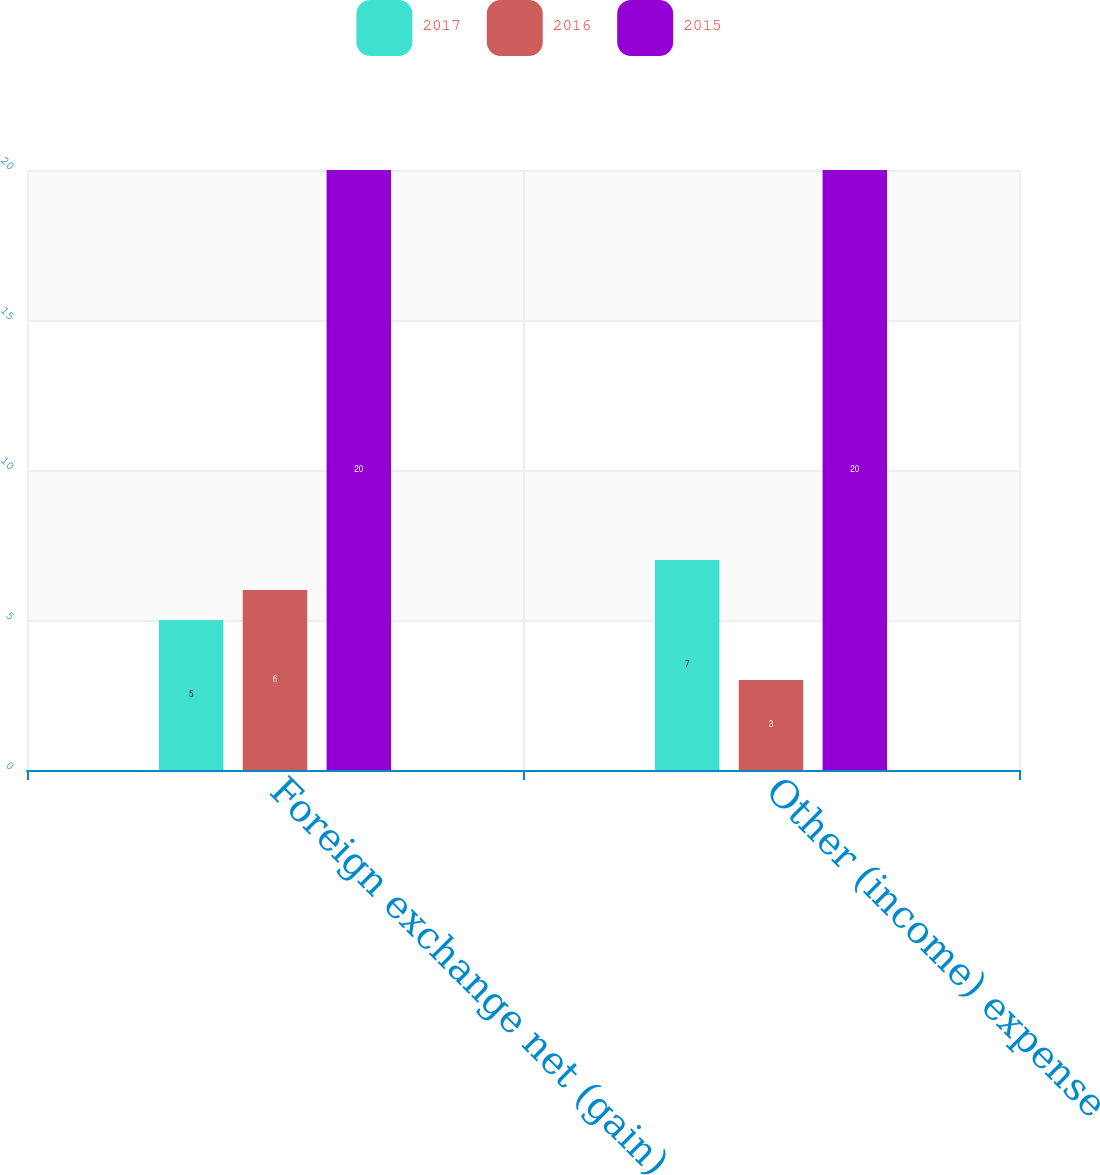<chart> <loc_0><loc_0><loc_500><loc_500><stacked_bar_chart><ecel><fcel>Foreign exchange net (gain)<fcel>Other (income) expense<nl><fcel>2017<fcel>5<fcel>7<nl><fcel>2016<fcel>6<fcel>3<nl><fcel>2015<fcel>20<fcel>20<nl></chart> 